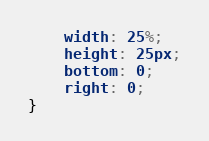<code> <loc_0><loc_0><loc_500><loc_500><_CSS_>    width: 25%;
    height: 25px;
    bottom: 0;
    right: 0;
}</code> 